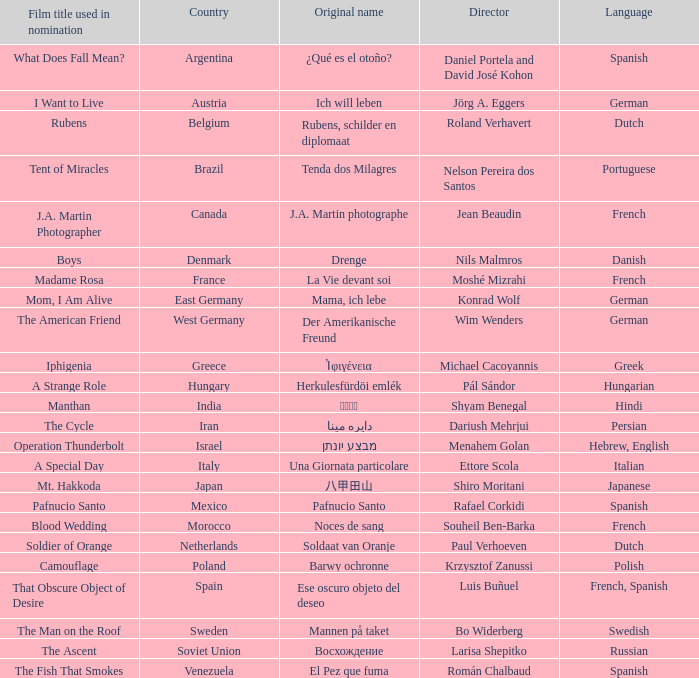Which country is the film Tent of Miracles from? Brazil. 